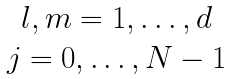<formula> <loc_0><loc_0><loc_500><loc_500>\begin{matrix} l , m = 1 , \dots , d \\ j = 0 , \dots , N - 1 \end{matrix}</formula> 